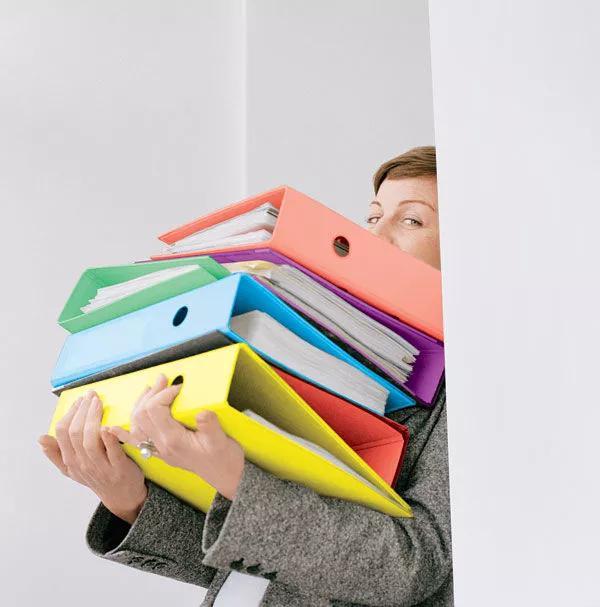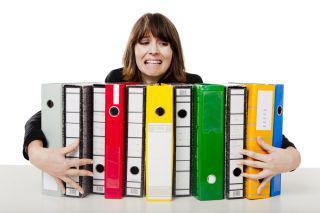The first image is the image on the left, the second image is the image on the right. Considering the images on both sides, is "A person is grasping a vertical stack of binders in one image." valid? Answer yes or no. Yes. The first image is the image on the left, the second image is the image on the right. Considering the images on both sides, is "there are at least five colored binders in the image on the left" valid? Answer yes or no. Yes. 